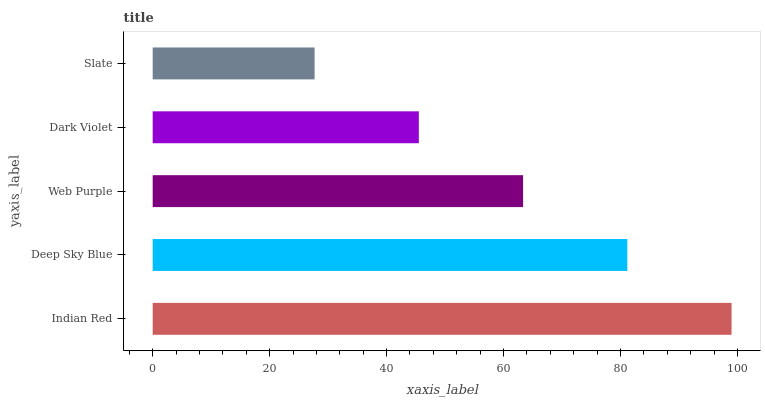Is Slate the minimum?
Answer yes or no. Yes. Is Indian Red the maximum?
Answer yes or no. Yes. Is Deep Sky Blue the minimum?
Answer yes or no. No. Is Deep Sky Blue the maximum?
Answer yes or no. No. Is Indian Red greater than Deep Sky Blue?
Answer yes or no. Yes. Is Deep Sky Blue less than Indian Red?
Answer yes or no. Yes. Is Deep Sky Blue greater than Indian Red?
Answer yes or no. No. Is Indian Red less than Deep Sky Blue?
Answer yes or no. No. Is Web Purple the high median?
Answer yes or no. Yes. Is Web Purple the low median?
Answer yes or no. Yes. Is Dark Violet the high median?
Answer yes or no. No. Is Dark Violet the low median?
Answer yes or no. No. 